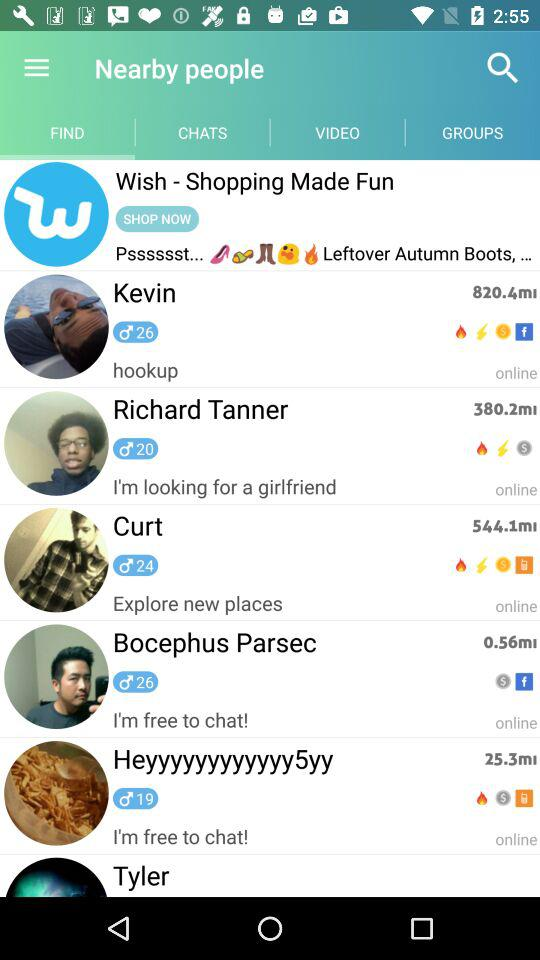What is the age of Curt? Curt is 24 years old. 